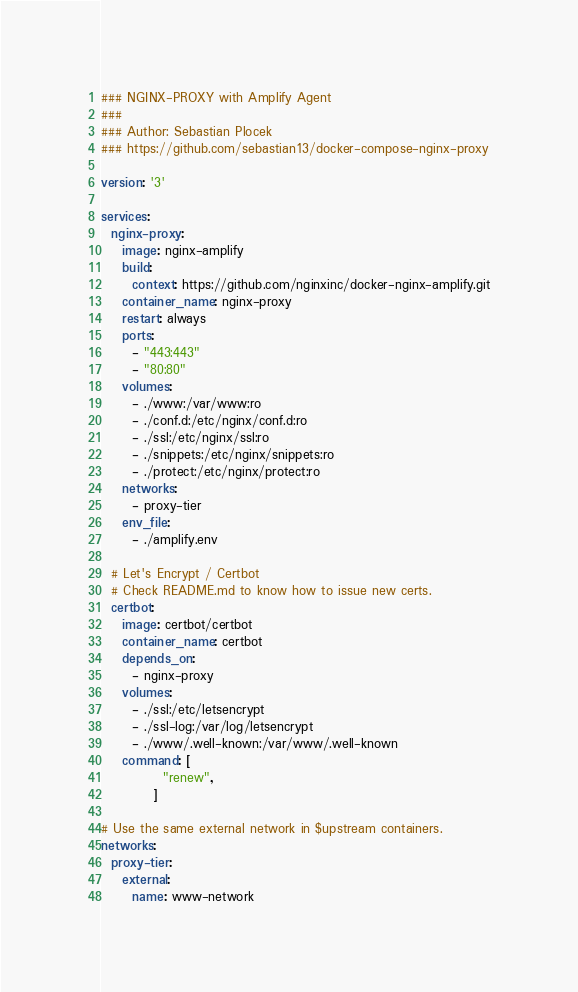Convert code to text. <code><loc_0><loc_0><loc_500><loc_500><_YAML_>### NGINX-PROXY with Amplify Agent
###
### Author: Sebastian Plocek
### https://github.com/sebastian13/docker-compose-nginx-proxy

version: '3'

services:
  nginx-proxy:
    image: nginx-amplify
    build:
      context: https://github.com/nginxinc/docker-nginx-amplify.git
    container_name: nginx-proxy
    restart: always
    ports:
      - "443:443"
      - "80:80"
    volumes:
      - ./www:/var/www:ro
      - ./conf.d:/etc/nginx/conf.d:ro
      - ./ssl:/etc/nginx/ssl:ro
      - ./snippets:/etc/nginx/snippets:ro
      - ./protect:/etc/nginx/protect:ro
    networks:
      - proxy-tier
    env_file:
      - ./amplify.env
        
  # Let's Encrypt / Certbot
  # Check README.md to know how to issue new certs.
  certbot:
    image: certbot/certbot
    container_name: certbot
    depends_on:
      - nginx-proxy
    volumes:
      - ./ssl:/etc/letsencrypt
      - ./ssl-log:/var/log/letsencrypt
      - ./www/.well-known:/var/www/.well-known
    command: [
            "renew",
          ]

# Use the same external network in $upstream containers.
networks:
  proxy-tier:
    external:
      name: www-network</code> 